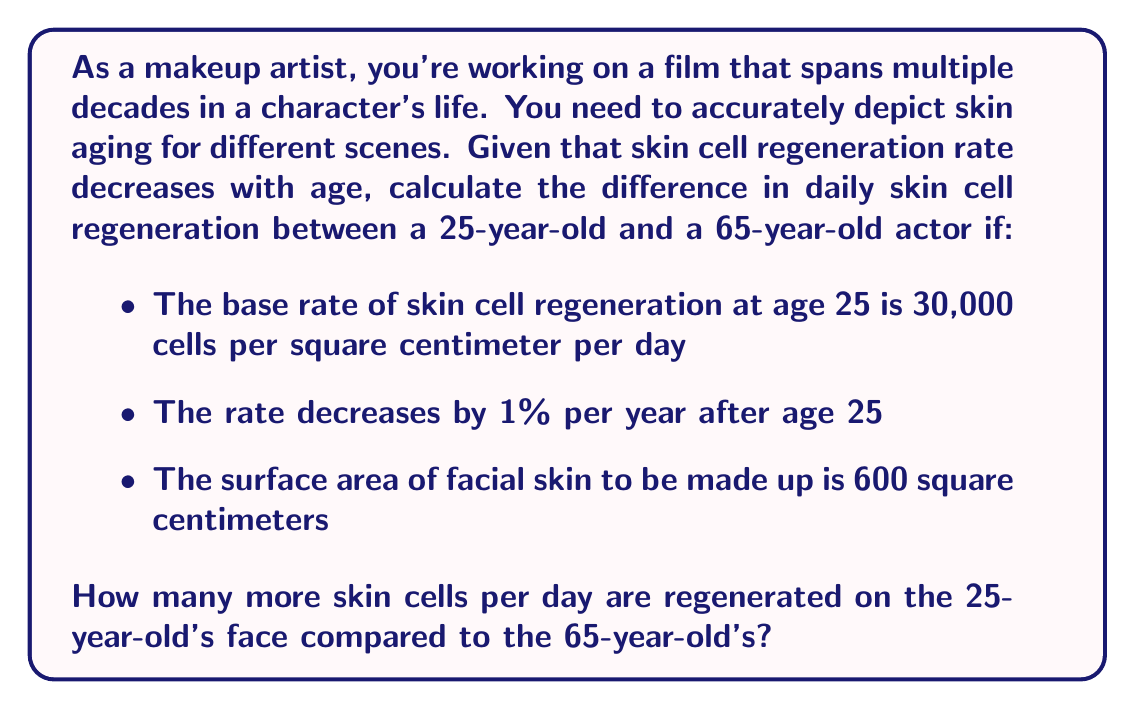Show me your answer to this math problem. To solve this problem, we'll follow these steps:

1. Calculate the skin cell regeneration rate for the 65-year-old:
   - Years since age 25: $65 - 25 = 40$ years
   - Decrease in rate: $1\% \times 40 = 40\%$
   - Remaining rate: $100\% - 40\% = 60\%$ of original
   - Rate at 65: $30,000 \times 0.60 = 18,000$ cells per cm² per day

2. Calculate total daily regeneration for each age:
   - For 25-year-old: $30,000 \times 600 = 18,000,000$ cells per day
   - For 65-year-old: $18,000 \times 600 = 10,800,000$ cells per day

3. Calculate the difference:
   $18,000,000 - 10,800,000 = 7,200,000$ cells per day

Let's express this mathematically:

$$\begin{align}
R_{25} &= 30,000 \text{ cells/cm²/day} \\
R_{65} &= R_{25} \times (1 - 0.01 \times 40) \\
&= 30,000 \times 0.60 \\
&= 18,000 \text{ cells/cm²/day} \\
\end{align}$$

$$\begin{align}
T_{25} &= R_{25} \times 600 \text{ cm²} = 18,000,000 \text{ cells/day} \\
T_{65} &= R_{65} \times 600 \text{ cm²} = 10,800,000 \text{ cells/day} \\
\end{align}$$

$$\text{Difference} = T_{25} - T_{65} = 7,200,000 \text{ cells/day}$$
Answer: The 25-year-old's face regenerates 7,200,000 more skin cells per day than the 65-year-old's face. 